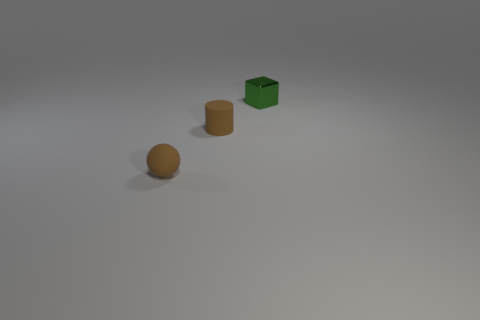What number of things are small matte balls or small green things? 2 